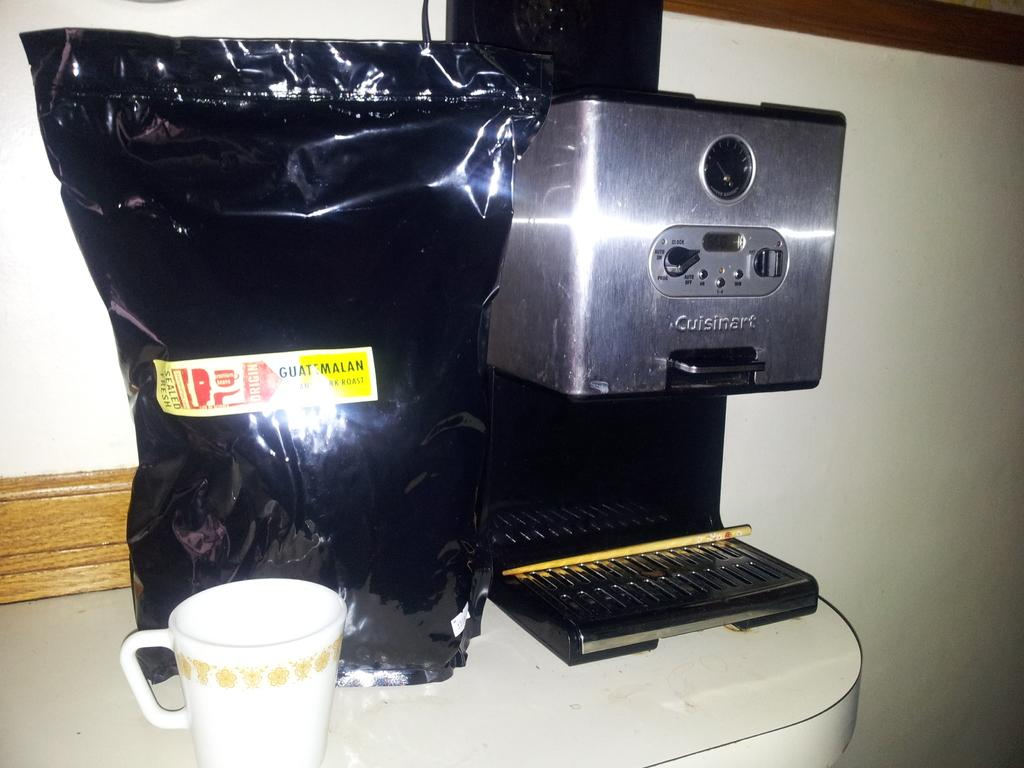<image>
Render a clear and concise summary of the photo. A bag of Guatamalan coffee sitting next to a coffee maker. 